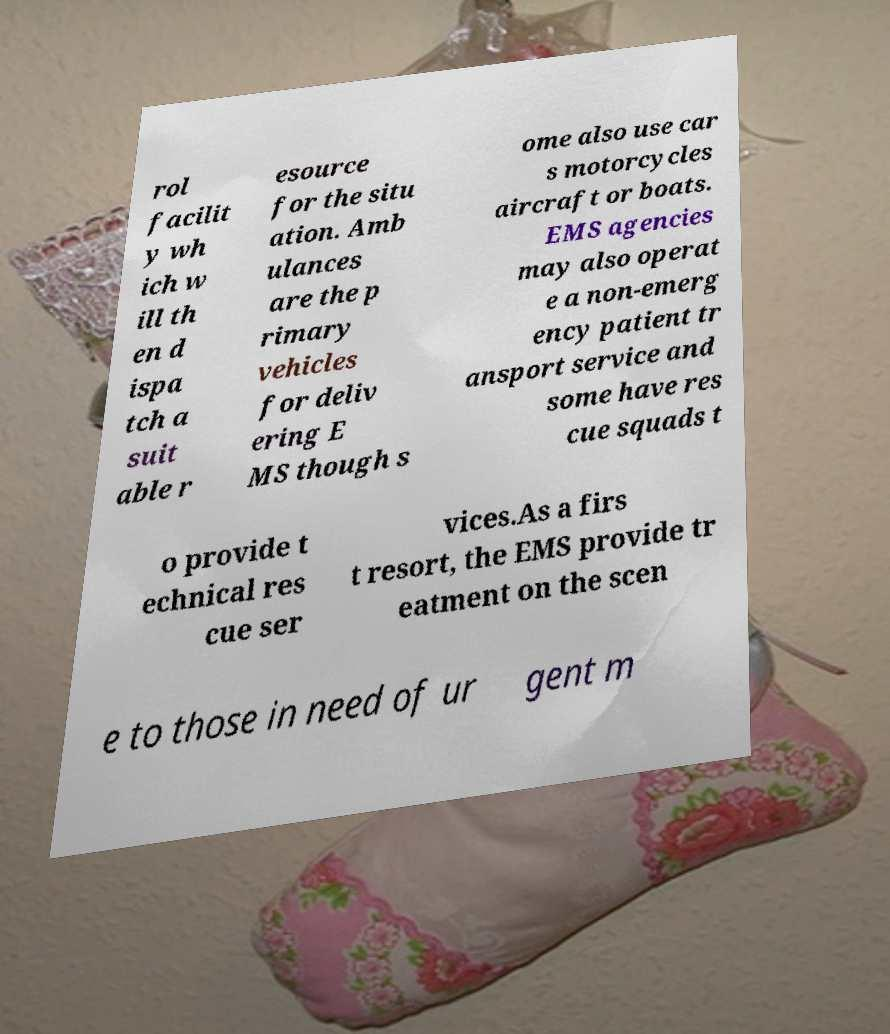Can you accurately transcribe the text from the provided image for me? rol facilit y wh ich w ill th en d ispa tch a suit able r esource for the situ ation. Amb ulances are the p rimary vehicles for deliv ering E MS though s ome also use car s motorcycles aircraft or boats. EMS agencies may also operat e a non-emerg ency patient tr ansport service and some have res cue squads t o provide t echnical res cue ser vices.As a firs t resort, the EMS provide tr eatment on the scen e to those in need of ur gent m 